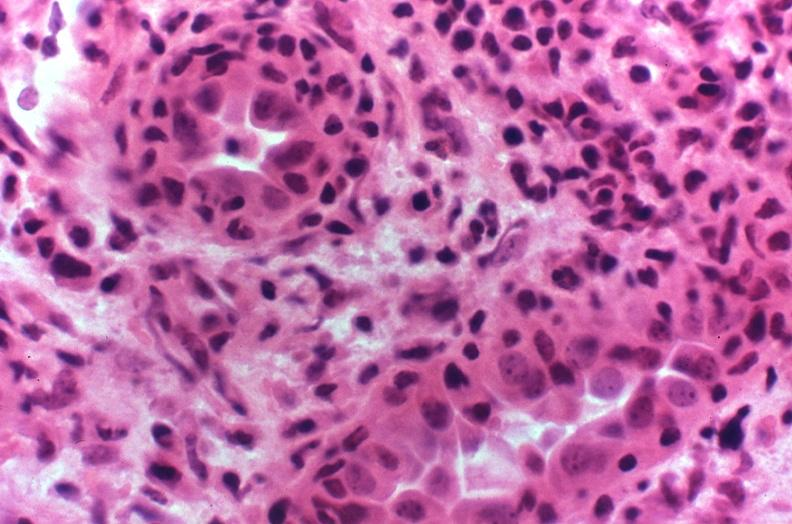does metastatic carcinoma oat cell show kidney transplant rejection?
Answer the question using a single word or phrase. No 